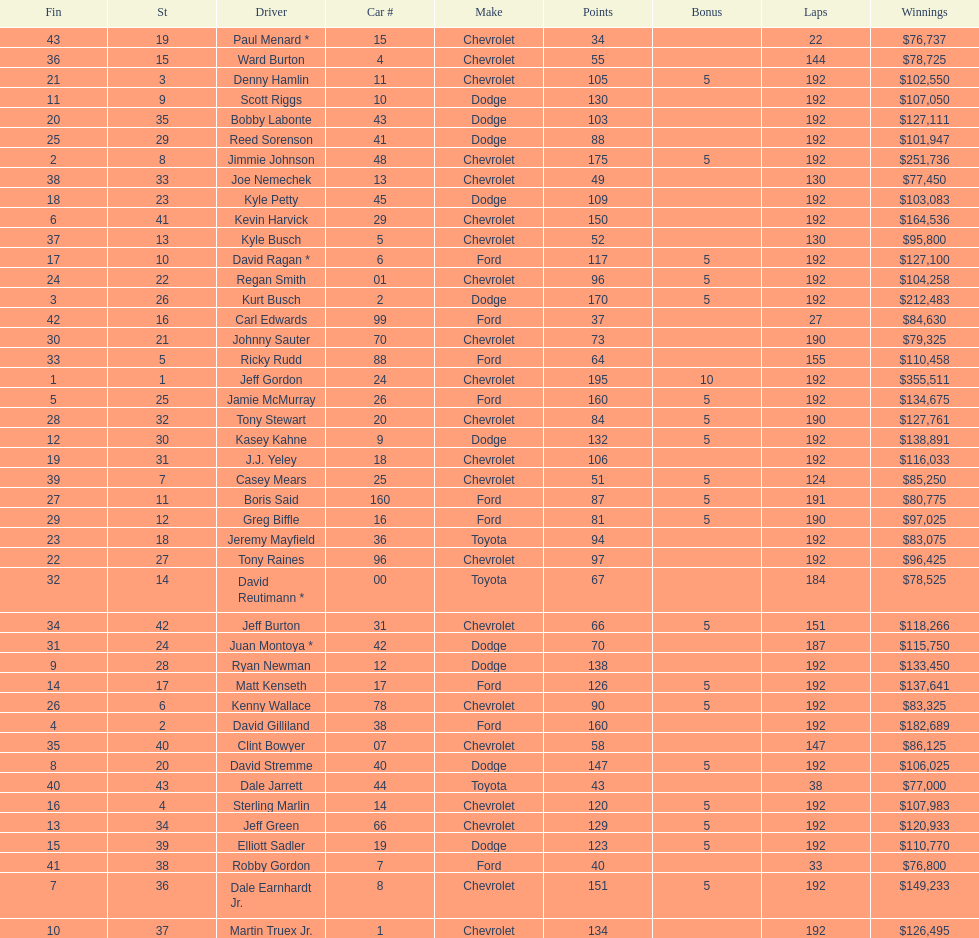What was jimmie johnson's winnings? $251,736. 